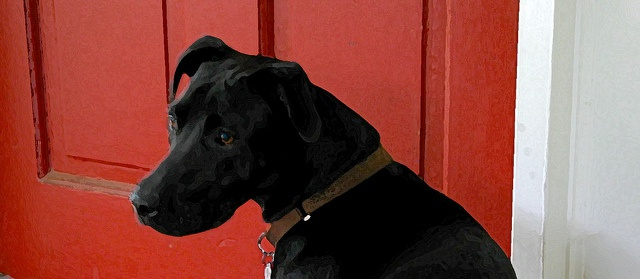Describe the objects in this image and their specific colors. I can see a dog in brown, black, maroon, and gray tones in this image. 